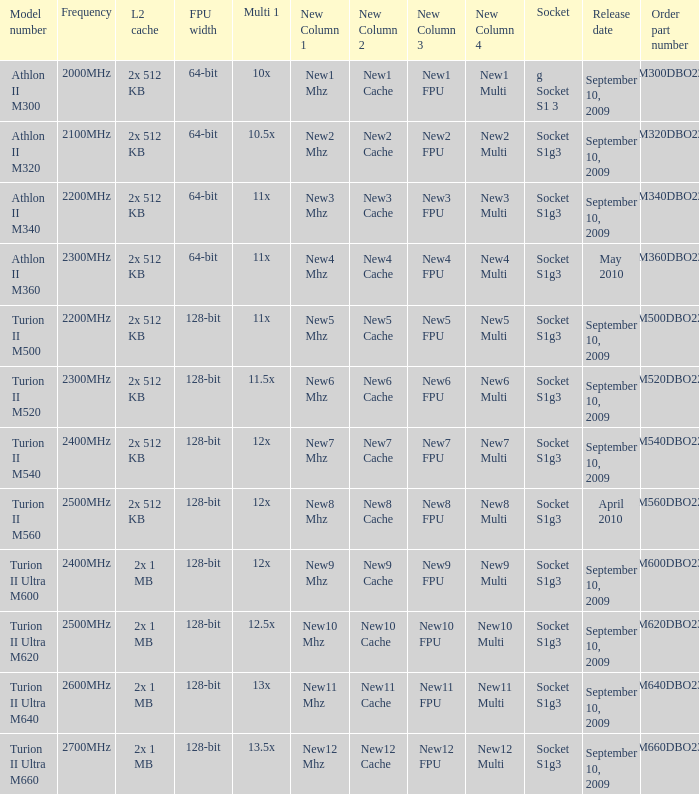What is the order part number with a 12.5x multi 1? TMM620DBO23GQ. 